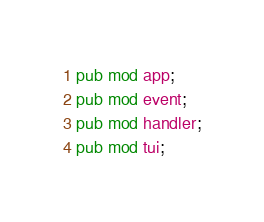<code> <loc_0><loc_0><loc_500><loc_500><_Rust_>pub mod app;
pub mod event;
pub mod handler;
pub mod tui;
</code> 